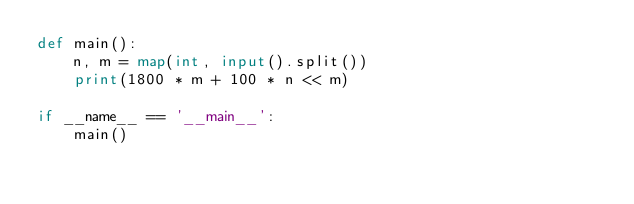<code> <loc_0><loc_0><loc_500><loc_500><_Python_>def main():
    n, m = map(int, input().split())    
    print(1800 * m + 100 * n << m)

if __name__ == '__main__':
    main()</code> 